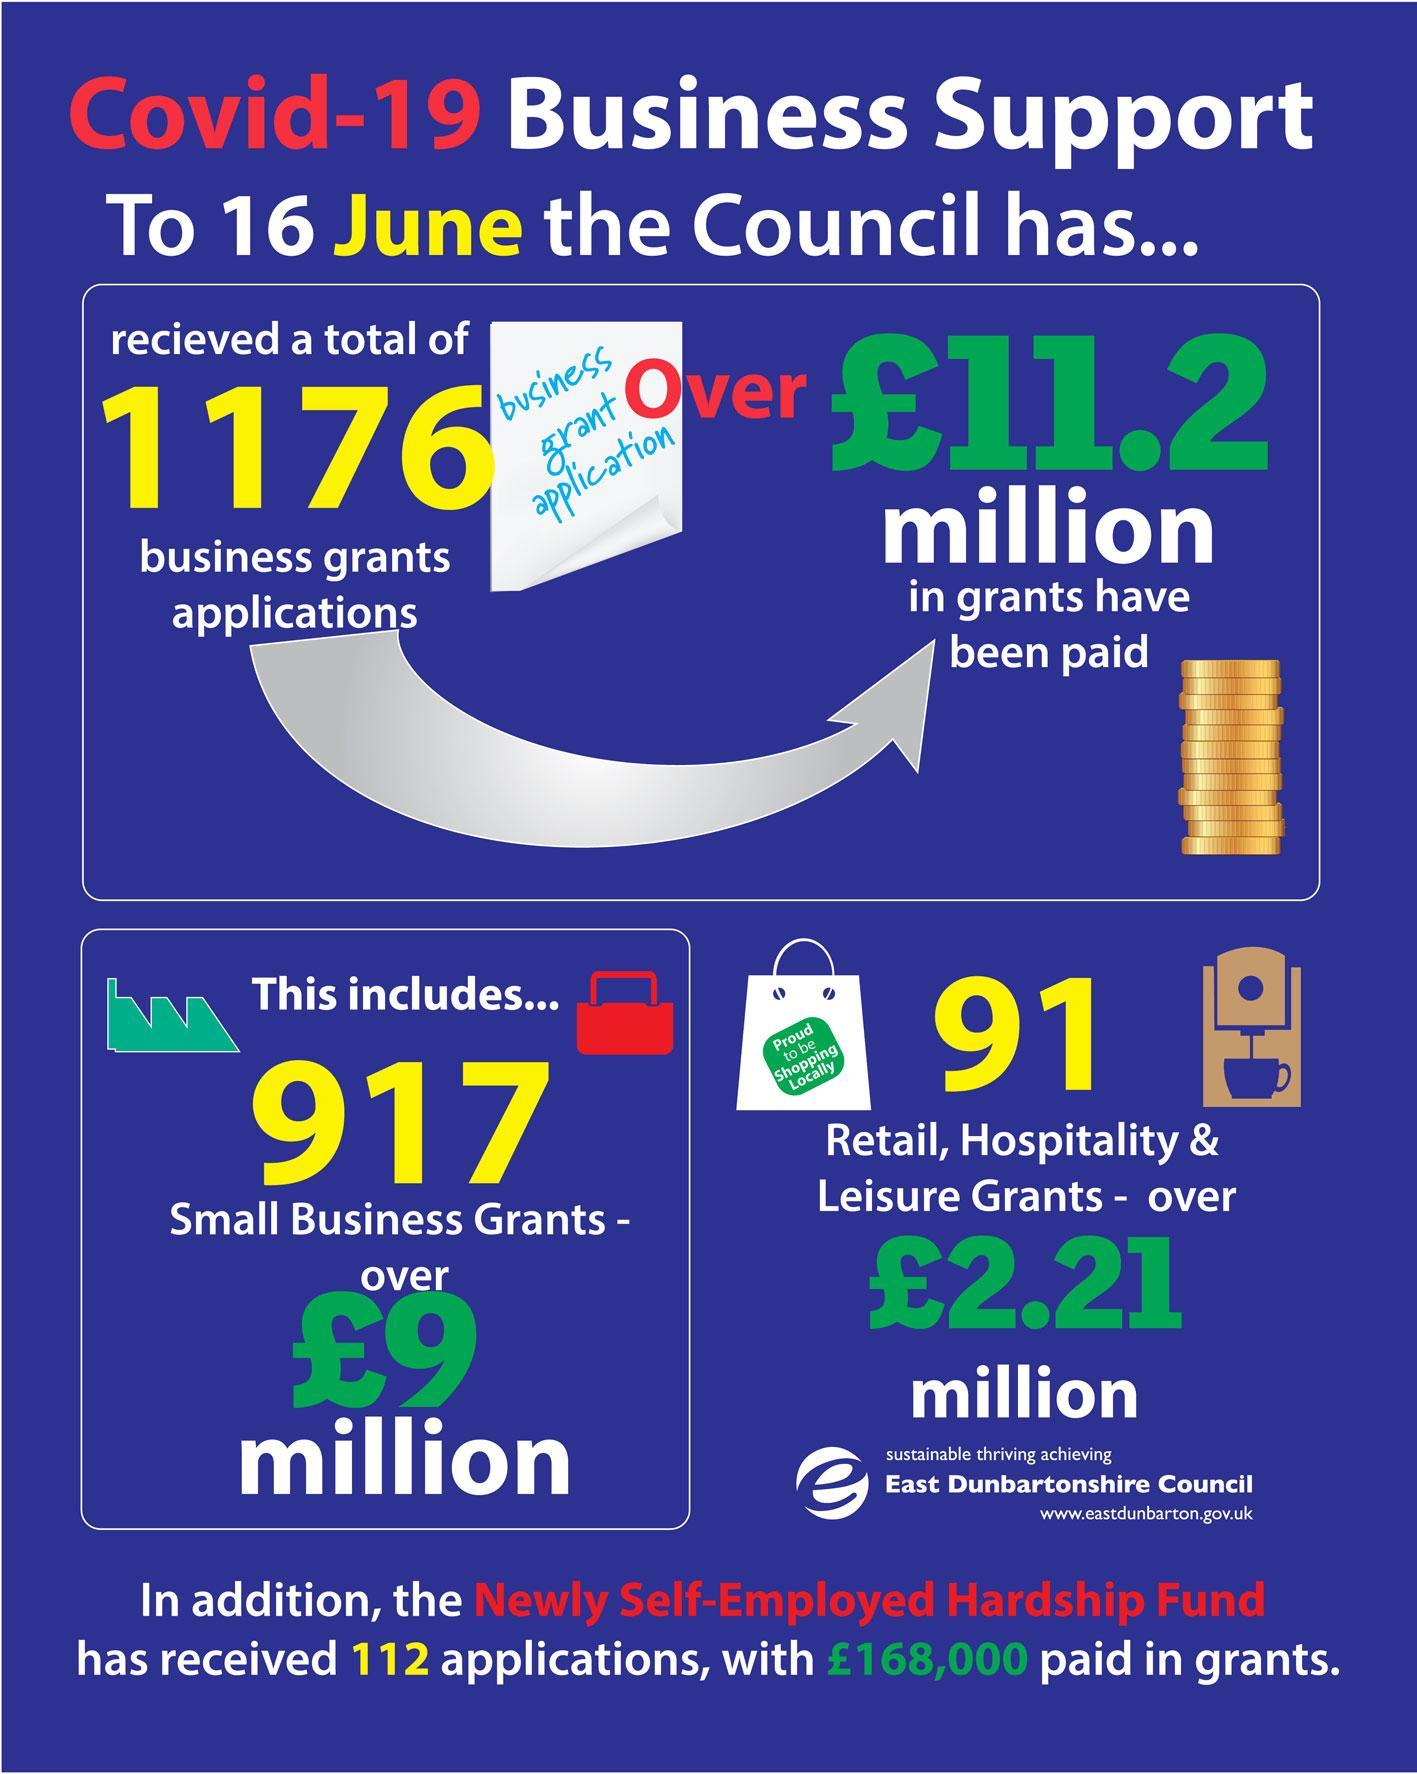How many small business grant applications were received by the East Dunbartonshire Council as of 16 June?
Answer the question with a short phrase. 917 What is the total number of business grant applications received by the East Dunbartonshire Council as of 16 June? 1176 What is the amount of total grants paid by the East Dunbartonshire Council as of 16 June? Over £11.2 million 